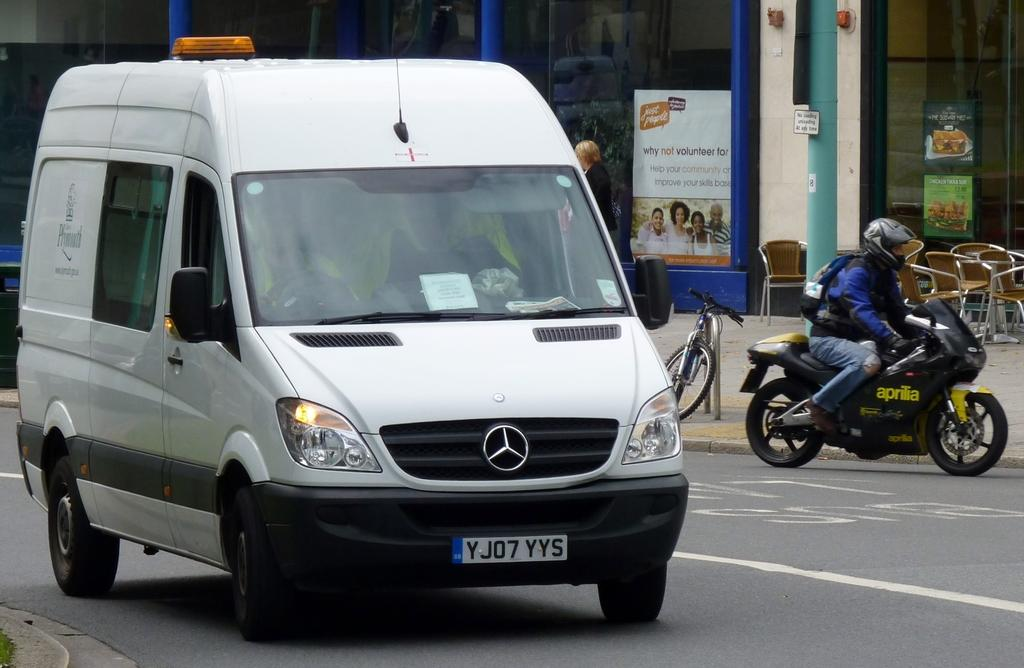<image>
Relay a brief, clear account of the picture shown. A white van has a license place that says YJ07YYS. 